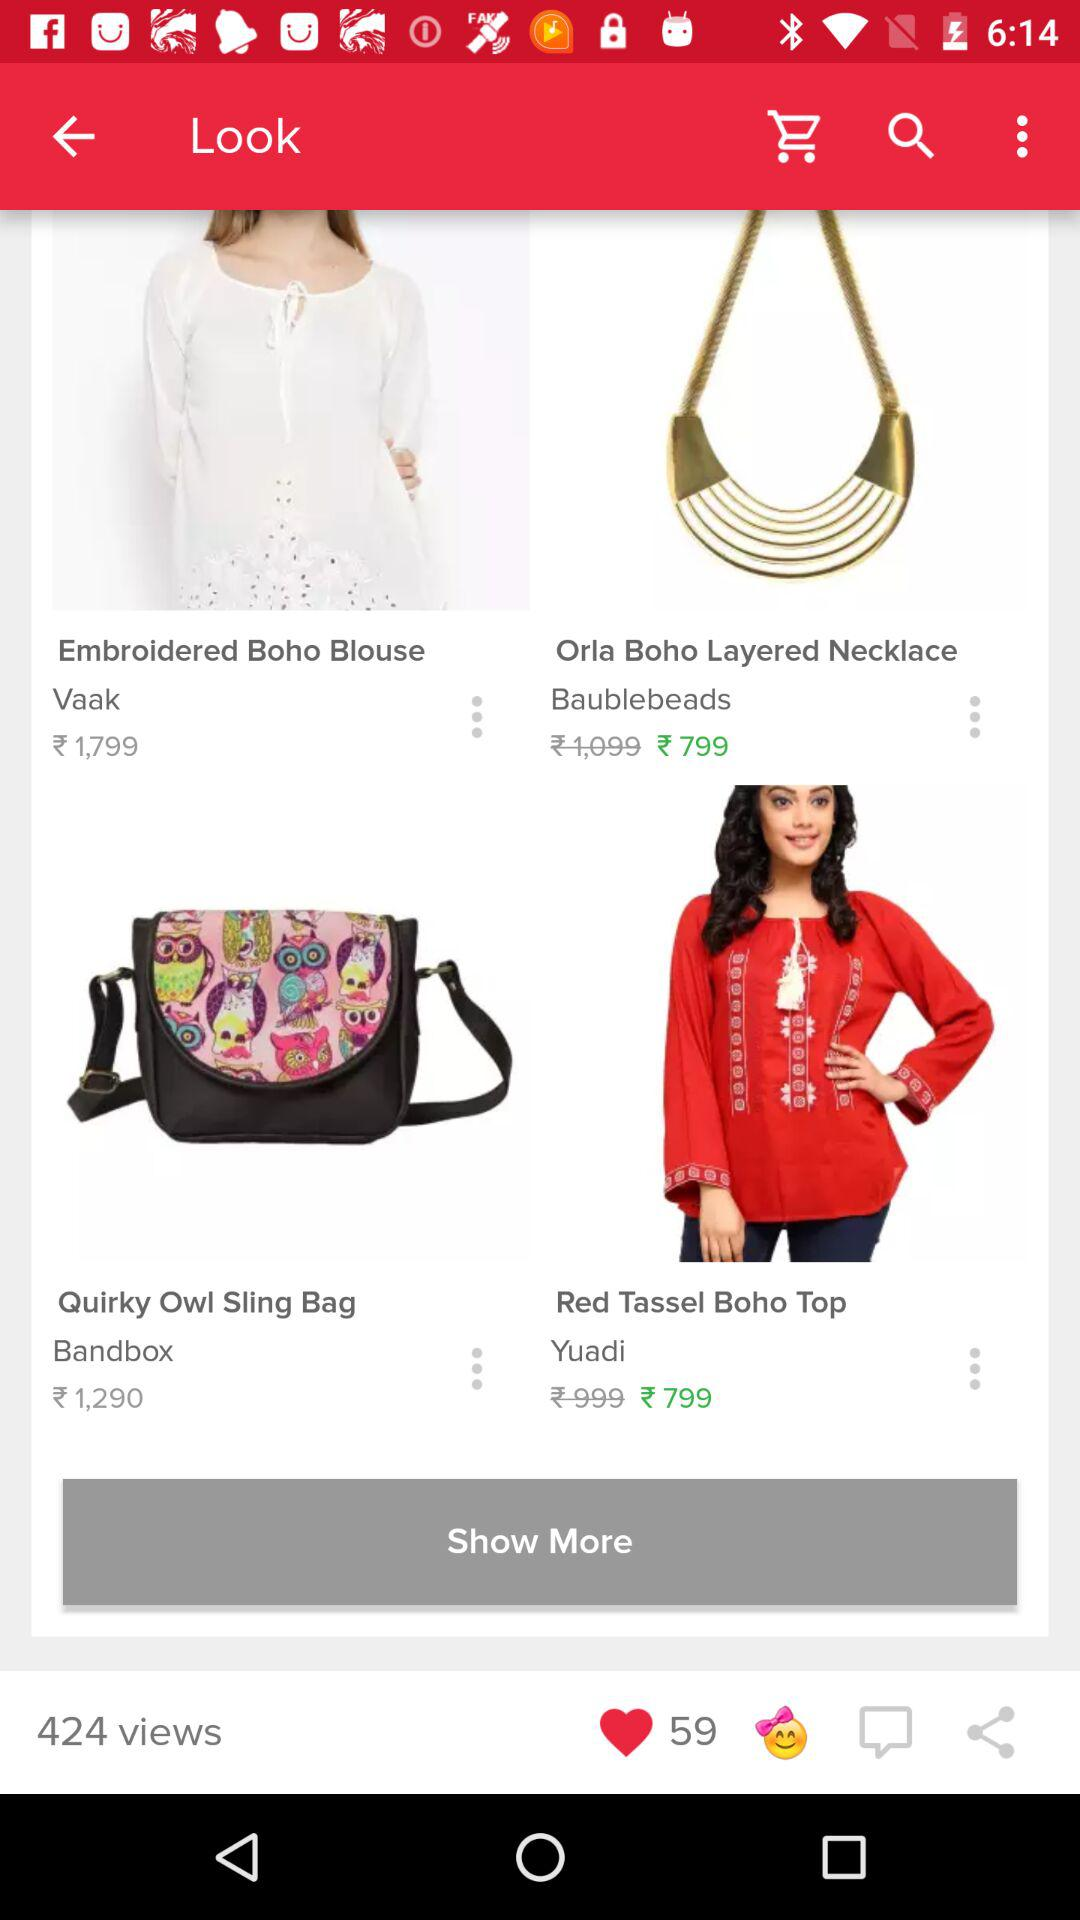What is the cost of the red tassel boho top after the discount? The cost is ₹799. 